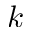Convert formula to latex. <formula><loc_0><loc_0><loc_500><loc_500>k</formula> 